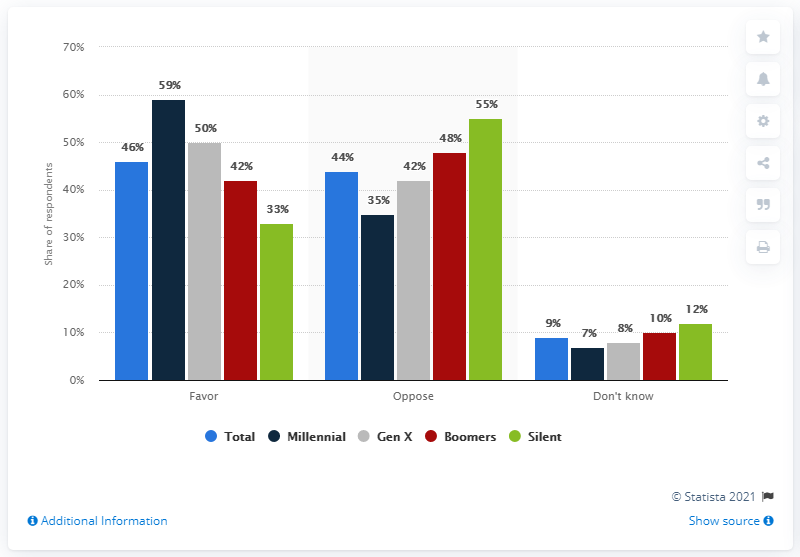Draw attention to some important aspects in this diagram. The color red indicates boomers. The sum of the highest and lowest values of the blue bar is 55. 